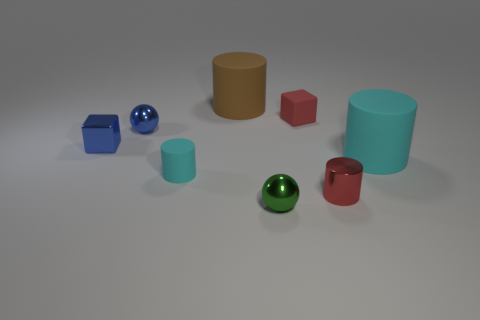Imagine this is a scene from a child's play area. Can you describe what activities might be happening here? Considering this as a child's play area scene, we might imagine children using the various shapes for creative play. They could be stacking blocks and cylinders to build structures, rolling the spheres in games of pretend bowling, or sorting the objects by color and shape. If these were game pieces, what game do you think they would be used for? If these were game pieces, they could be part of an educational game designed to teach children about shapes, volumes, and colors. Each shape might represent an element of the game where players have to match or collect items based on the game's rules, encouraging learning through interaction and play. 